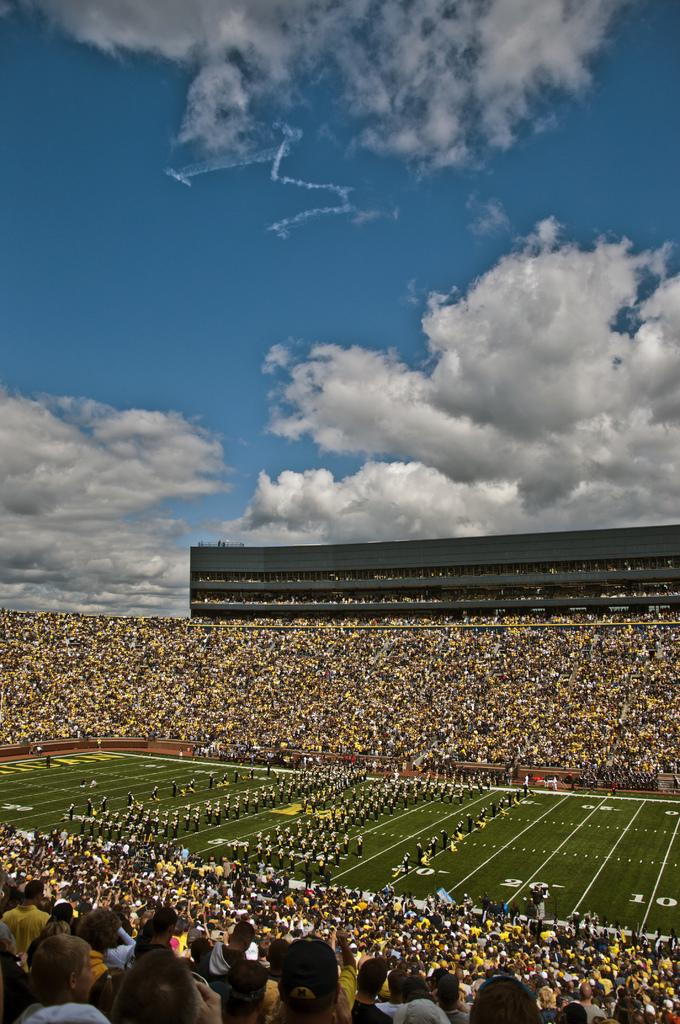What type of venue is depicted in the image? There is a stadium in the image. What activity is taking place in the stadium? There are players standing on the ground in the stadium. Can you describe the audience in the image? There is a crowd surrounding the ground in the stadium. What type of furniture can be seen in the image? There is no furniture present in the image; it features a stadium with players and a crowd. What kind of flame is visible in the image? There is no flame present in the image; it features a stadium with players and a crowd. 